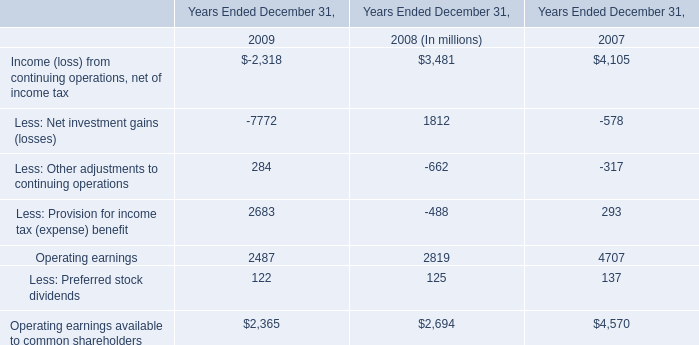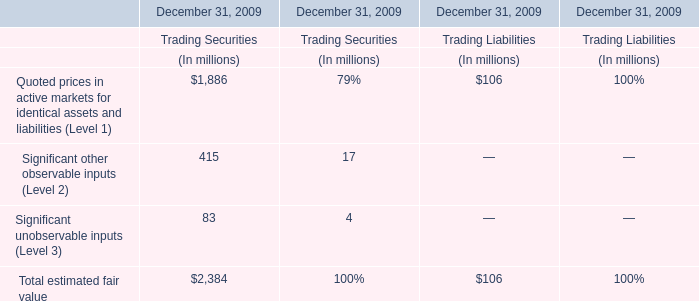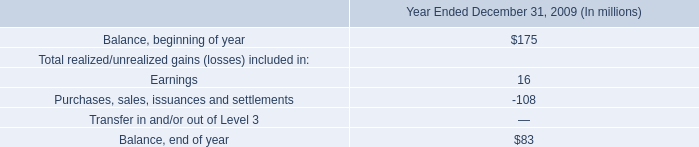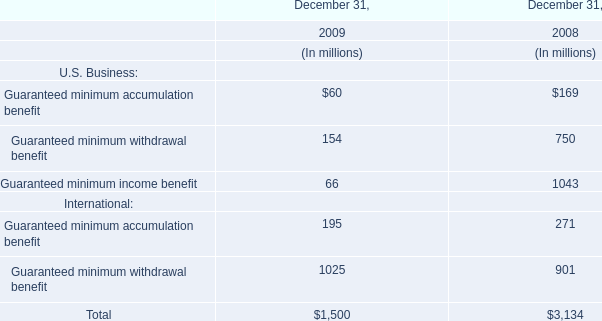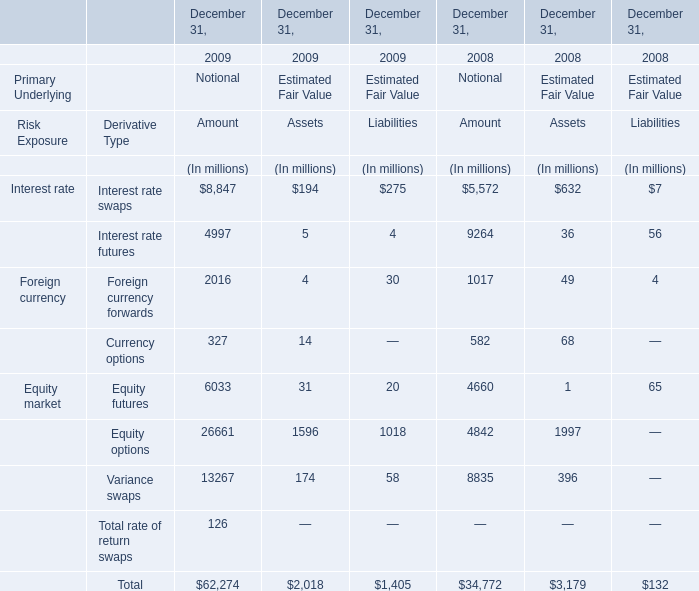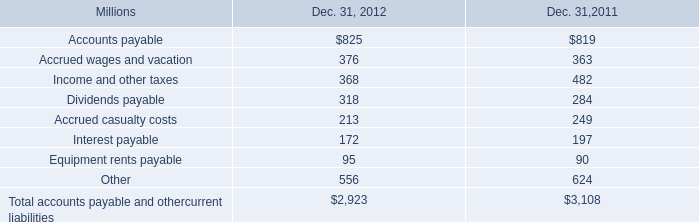As As the chart 4 shows,which year is Total Assets at Estimated Fair Value on December 31 lower than 3000 million? 
Answer: 2009. 